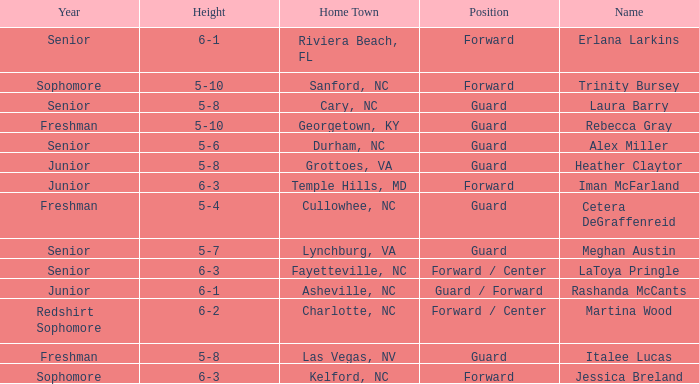What is the height of the player from Las Vegas, NV? 5-8. 